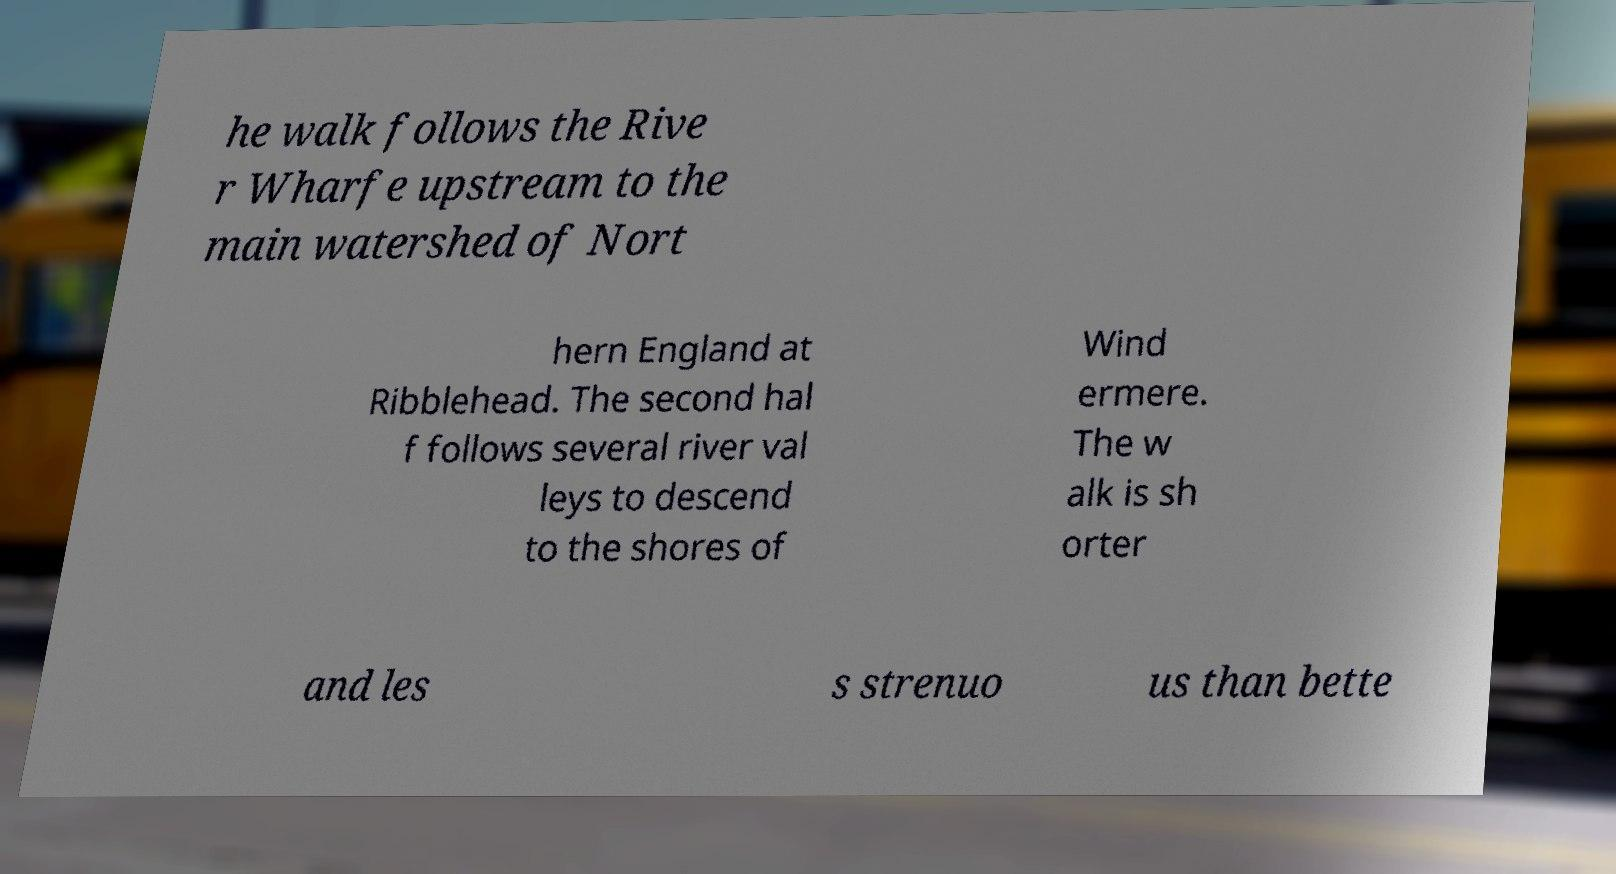Can you read and provide the text displayed in the image?This photo seems to have some interesting text. Can you extract and type it out for me? he walk follows the Rive r Wharfe upstream to the main watershed of Nort hern England at Ribblehead. The second hal f follows several river val leys to descend to the shores of Wind ermere. The w alk is sh orter and les s strenuo us than bette 